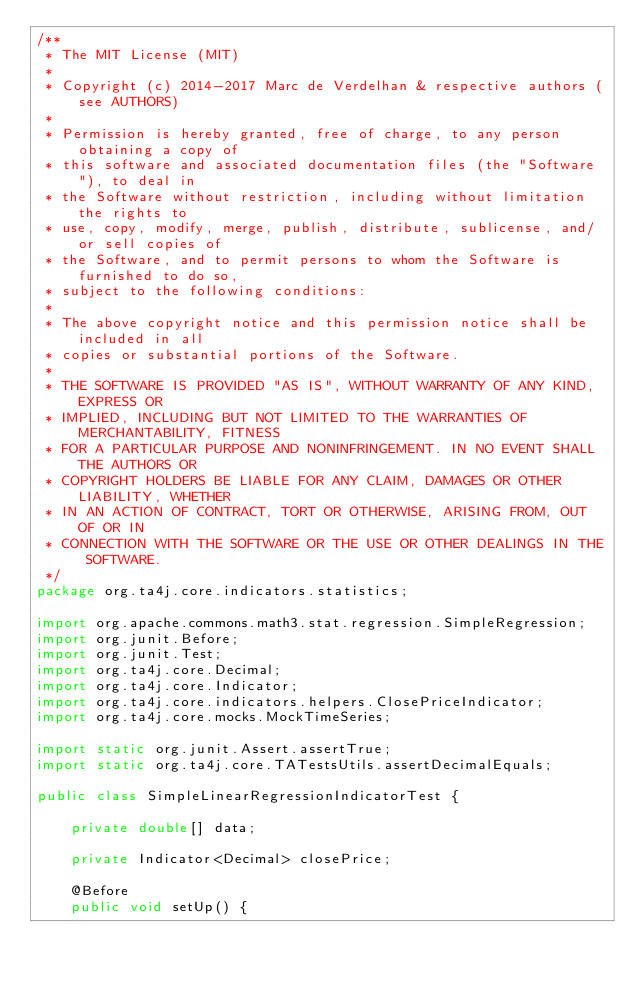<code> <loc_0><loc_0><loc_500><loc_500><_Java_>/**
 * The MIT License (MIT)
 *
 * Copyright (c) 2014-2017 Marc de Verdelhan & respective authors (see AUTHORS)
 *
 * Permission is hereby granted, free of charge, to any person obtaining a copy of
 * this software and associated documentation files (the "Software"), to deal in
 * the Software without restriction, including without limitation the rights to
 * use, copy, modify, merge, publish, distribute, sublicense, and/or sell copies of
 * the Software, and to permit persons to whom the Software is furnished to do so,
 * subject to the following conditions:
 *
 * The above copyright notice and this permission notice shall be included in all
 * copies or substantial portions of the Software.
 *
 * THE SOFTWARE IS PROVIDED "AS IS", WITHOUT WARRANTY OF ANY KIND, EXPRESS OR
 * IMPLIED, INCLUDING BUT NOT LIMITED TO THE WARRANTIES OF MERCHANTABILITY, FITNESS
 * FOR A PARTICULAR PURPOSE AND NONINFRINGEMENT. IN NO EVENT SHALL THE AUTHORS OR
 * COPYRIGHT HOLDERS BE LIABLE FOR ANY CLAIM, DAMAGES OR OTHER LIABILITY, WHETHER
 * IN AN ACTION OF CONTRACT, TORT OR OTHERWISE, ARISING FROM, OUT OF OR IN
 * CONNECTION WITH THE SOFTWARE OR THE USE OR OTHER DEALINGS IN THE SOFTWARE.
 */
package org.ta4j.core.indicators.statistics;

import org.apache.commons.math3.stat.regression.SimpleRegression;
import org.junit.Before;
import org.junit.Test;
import org.ta4j.core.Decimal;
import org.ta4j.core.Indicator;
import org.ta4j.core.indicators.helpers.ClosePriceIndicator;
import org.ta4j.core.mocks.MockTimeSeries;

import static org.junit.Assert.assertTrue;
import static org.ta4j.core.TATestsUtils.assertDecimalEquals;

public class SimpleLinearRegressionIndicatorTest {

    private double[] data;
    
    private Indicator<Decimal> closePrice;
    
    @Before
    public void setUp() {</code> 